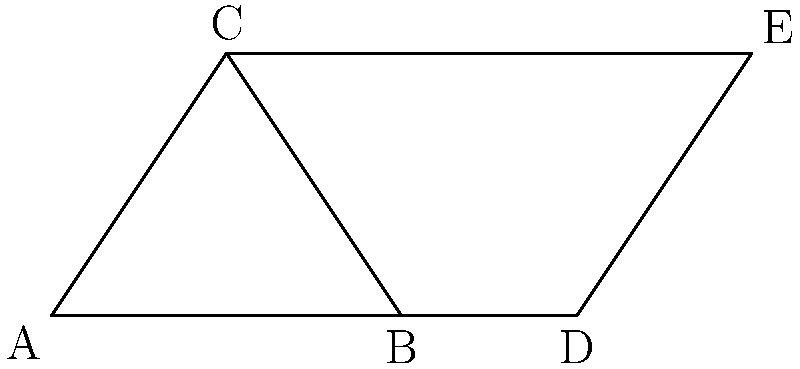In the alleged Martian pyramid complex, two triangular structures ABC and BDE share a common base BD. If angle ABC measures $x°$ and angle BDE measures $y°$, what is the relationship between $x$ and $y$ assuming Earth-like geometry applies on Mars? To determine the relationship between angles $x$ and $y$, we'll follow these steps:

1. Recognize that triangles ABC and BDE share a common base BD.

2. In triangle ABC:
   - Angle ABC = $x°$
   - The sum of angles in a triangle is 180°

3. In triangle BDE:
   - Angle BDE = $y°$
   - The sum of angles in a triangle is 180°

4. Consider the line CE:
   - It forms a transversal cutting the parallel lines AC and BE

5. Recall the alternate interior angles theorem:
   - When a transversal cuts two parallel lines, alternate interior angles are congruent

6. Observe that:
   - Angle BCA is an alternate interior angle to angle BED

7. Therefore:
   - Angle BCA = Angle BED

8. Since angle BCA in triangle ABC corresponds to angle BED in triangle BDE:
   - $x° = y°$

Thus, assuming Earth-like geometry applies on Mars, angles $x$ and $y$ are congruent.
Answer: $x = y$ 